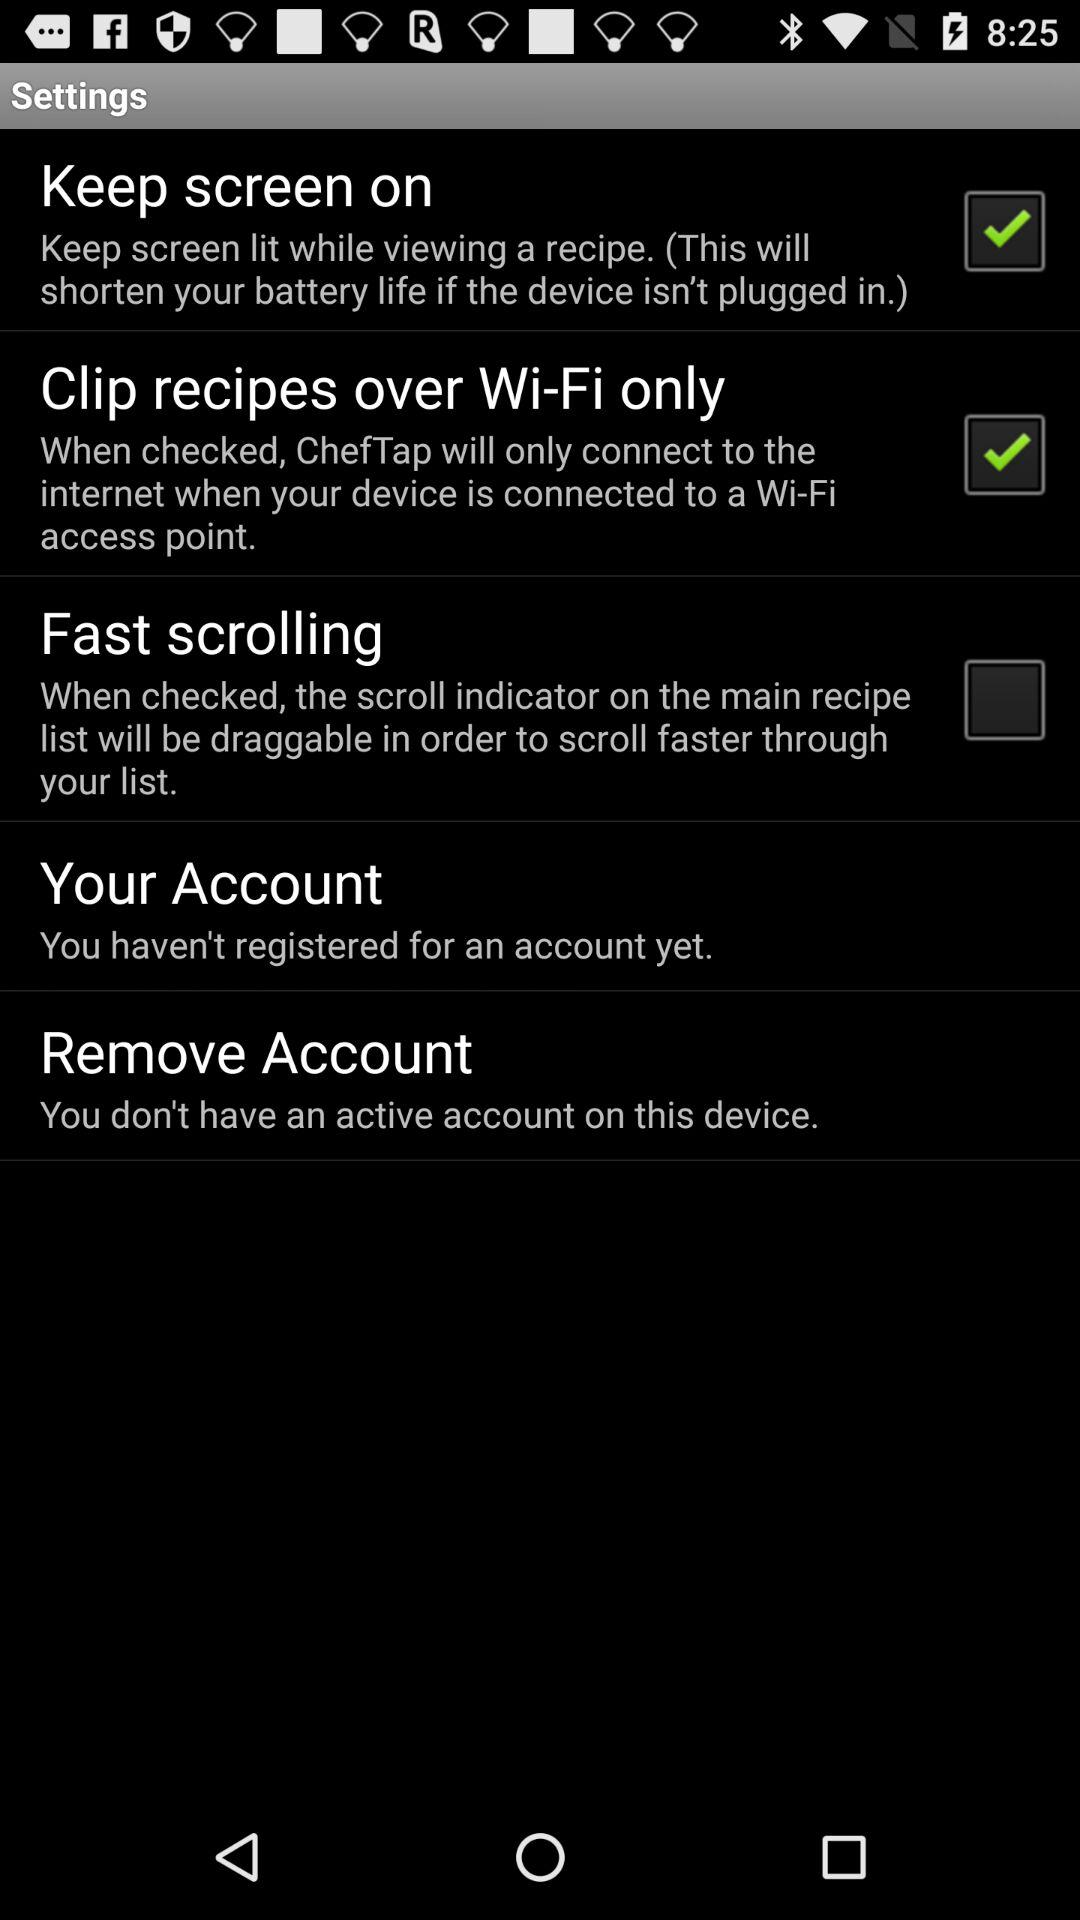What is the status of the keep screen on? The status is on. 